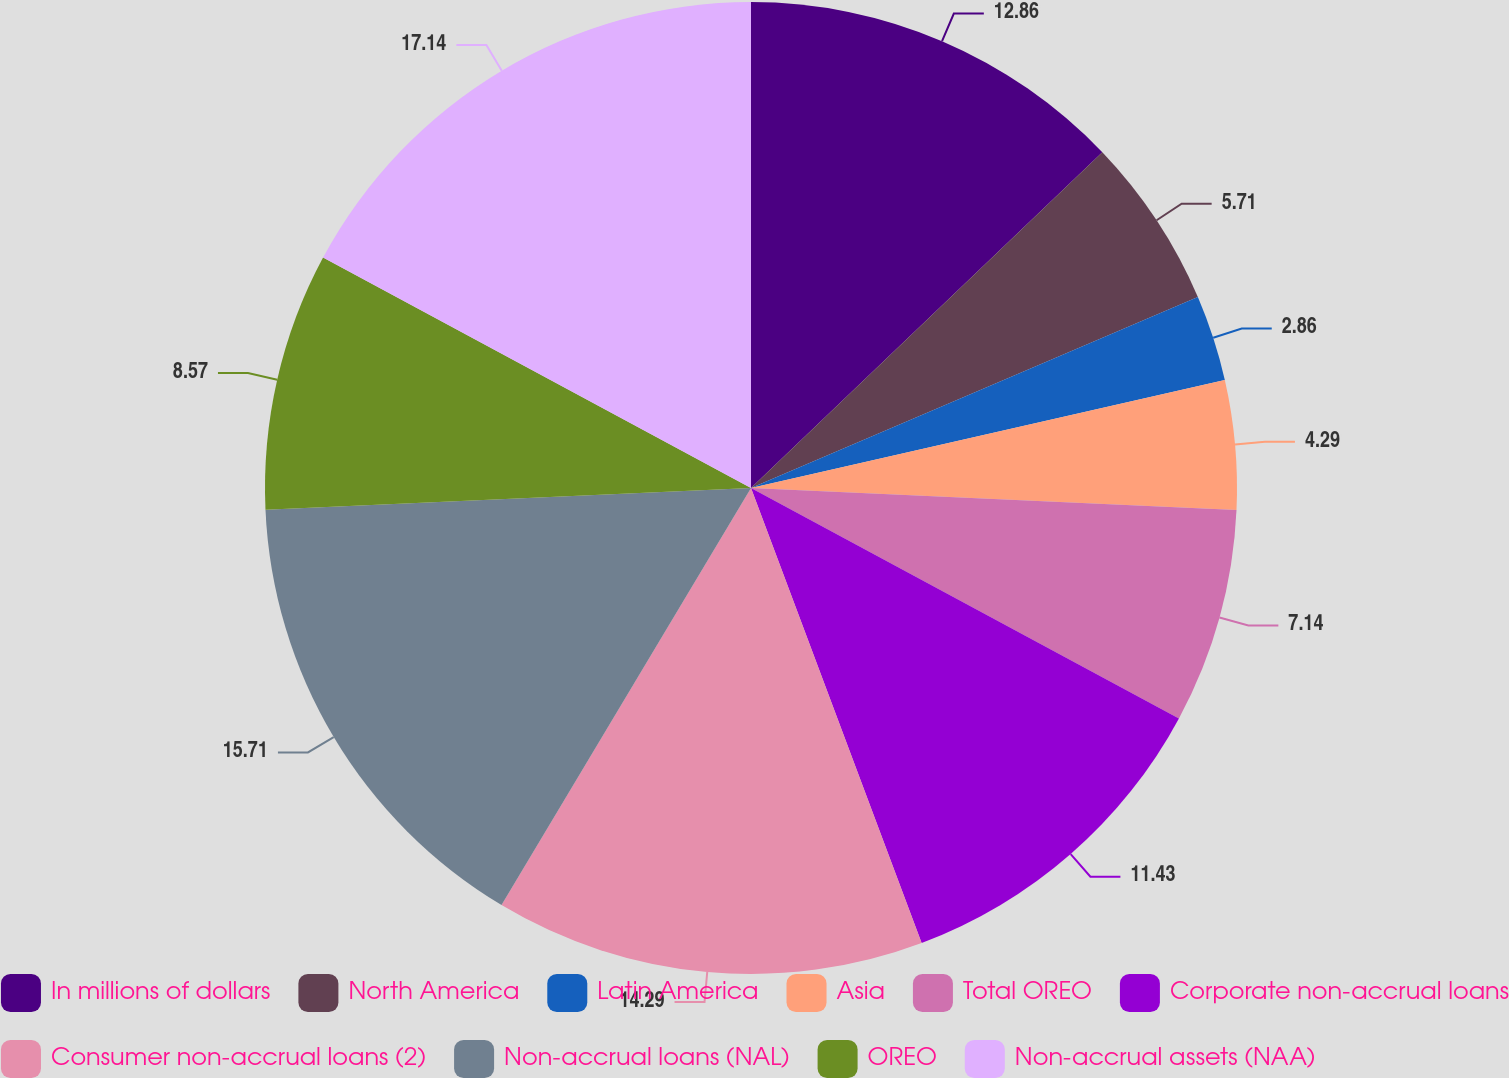Convert chart to OTSL. <chart><loc_0><loc_0><loc_500><loc_500><pie_chart><fcel>In millions of dollars<fcel>North America<fcel>Latin America<fcel>Asia<fcel>Total OREO<fcel>Corporate non-accrual loans<fcel>Consumer non-accrual loans (2)<fcel>Non-accrual loans (NAL)<fcel>OREO<fcel>Non-accrual assets (NAA)<nl><fcel>12.86%<fcel>5.71%<fcel>2.86%<fcel>4.29%<fcel>7.14%<fcel>11.43%<fcel>14.29%<fcel>15.71%<fcel>8.57%<fcel>17.14%<nl></chart> 